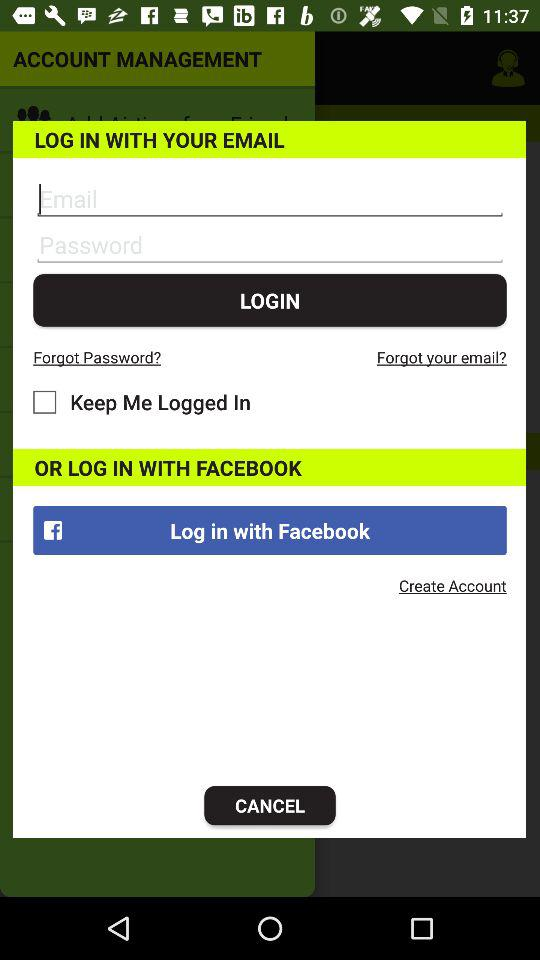How can we log in? You can log in with "EMAIL" and "FACEBOOK". 